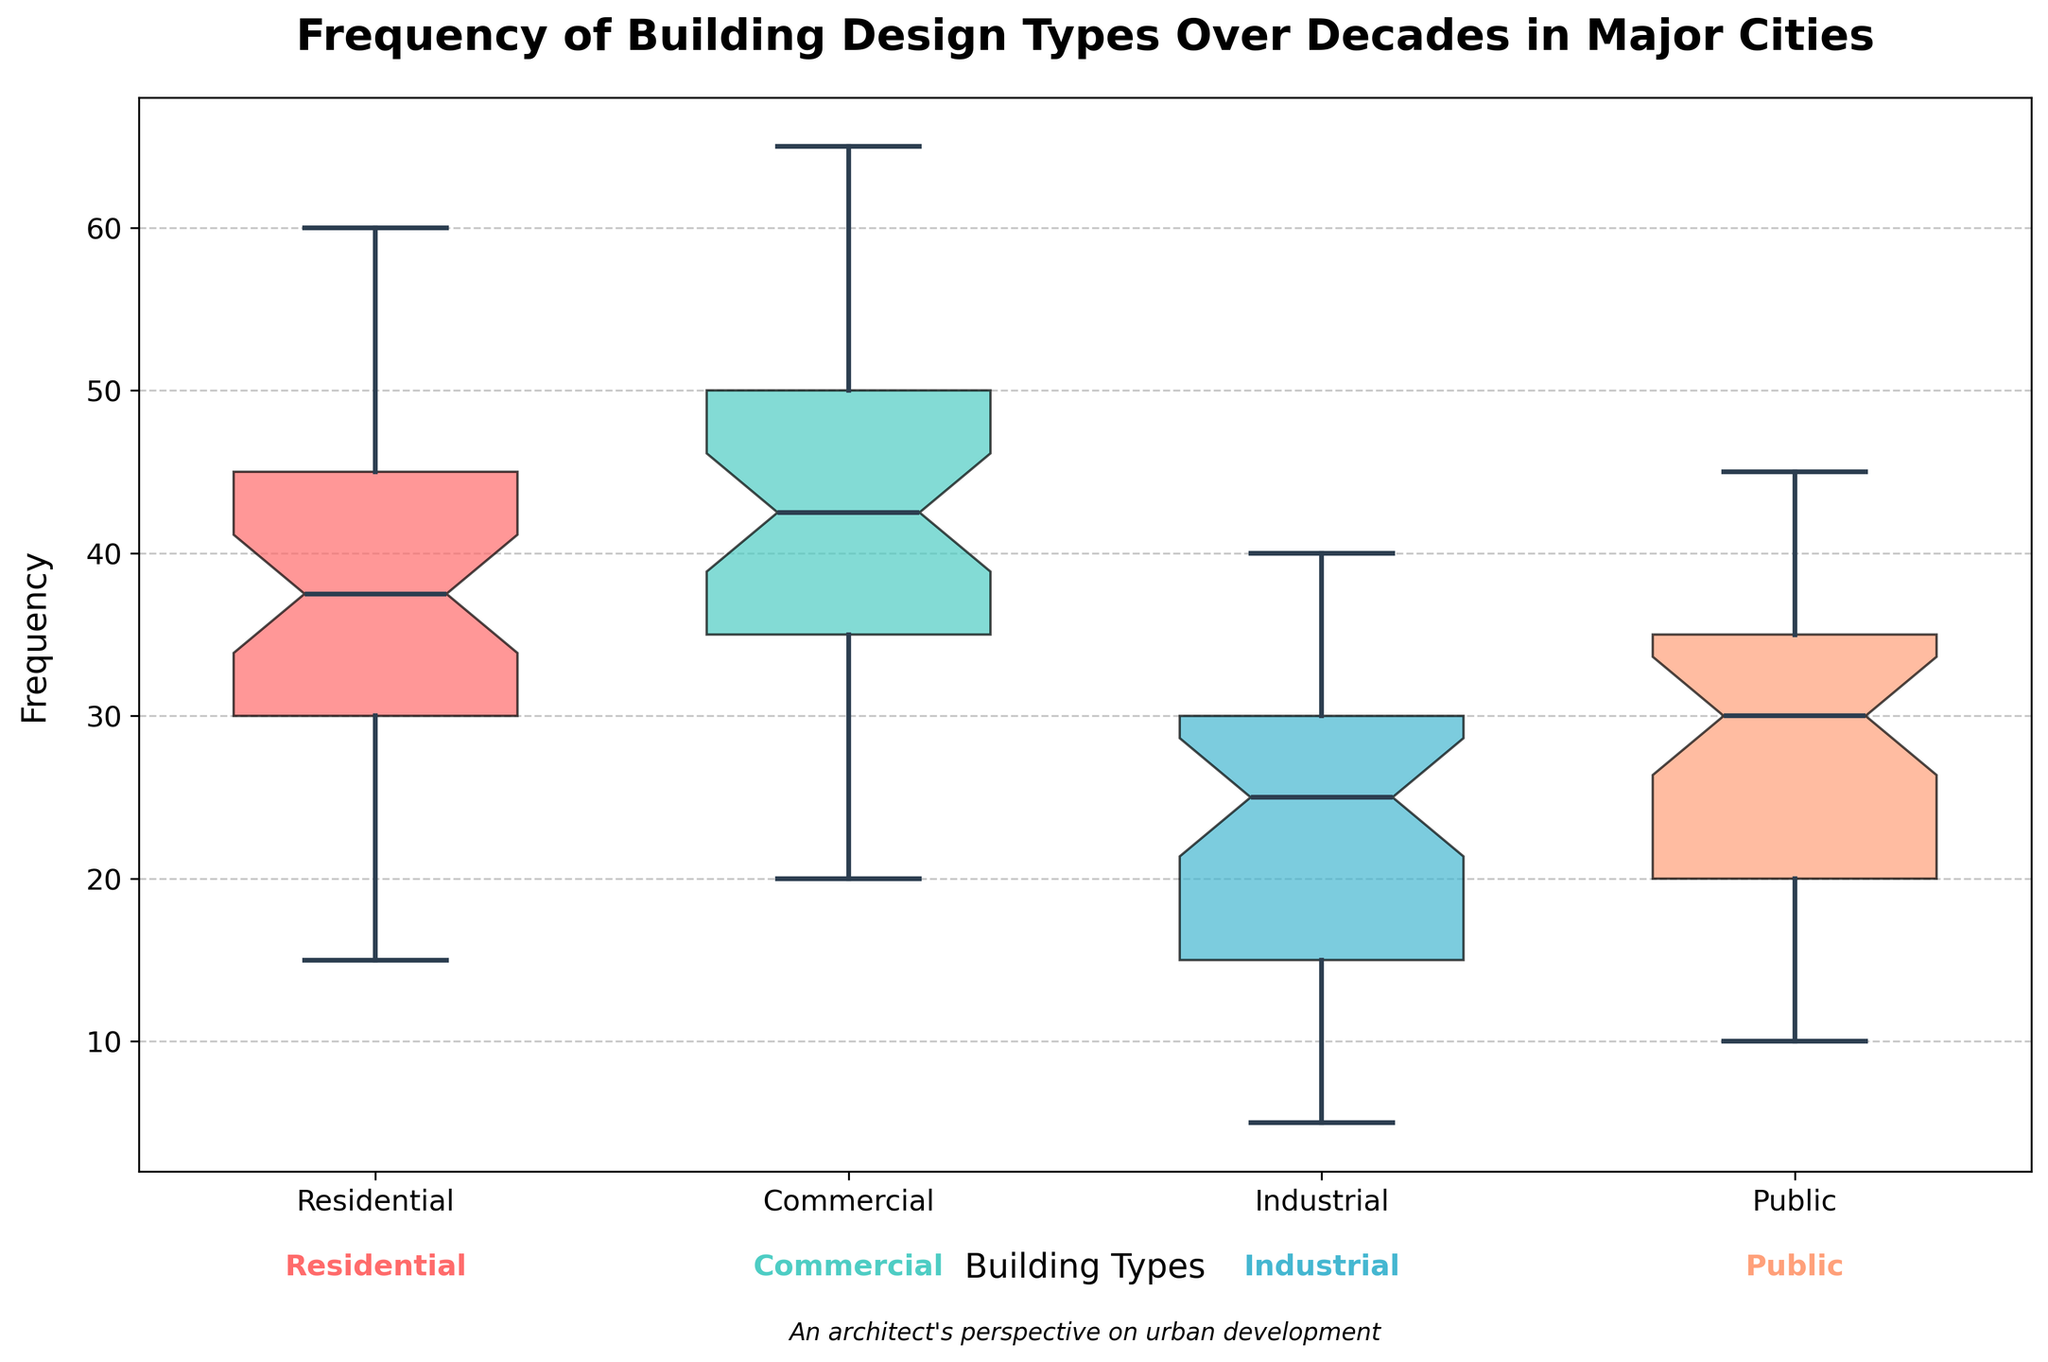What is the title of the figure? The title is typically at the top of a chart and describes what the chart is about. Here, it is bold and contains the main topic.
Answer: Frequency of Building Design Types Over Decades in Major Cities Which building type has the highest median frequency? To find the median frequency for each type, look for the central line inside each box. The type with the highest median line is the one with the highest median frequency.
Answer: Public Which building type shows the widest range in frequency? The range is identified by the length of the box (Interquartile Range) and the whiskers. Examine the box and whisker lengths across the building types to determine which is the widest.
Answer: Residential What's the frequency range for the Commercial building type? The range is the difference between the maximum and minimum values. Look at the top and bottom whiskers for Commercial to determine these values.
Answer: 25-65 Which building type has the least variability in frequency? Variability in a box plot is typically assessed by the length of the box and whiskers. The type with the shortest total length of box and whiskers has the least variability.
Answer: Industrial Is there an outlier in any building type? Outliers in a box plot are typically marked by individual points outside the whiskers. Check for any marked points outside the whiskers for all building types.
Answer: Yes, in Industrial What's the interquartile range (IQR) for Public building types? IQR is the difference between the upper quartile (top of the box) and the lower quartile (bottom of the box). Measure this difference for the Public building type.
Answer: 20 How does the median of Residential compare to the median of Industrial? Compare the central lines inside the boxes of Residential and Industrial. Determine which is higher or if they are equal.
Answer: Residential's median is higher Are there more data points indicating higher frequencies in Public or Industrial building types? This can be assessed by examining the box and whisker lengths and the presence of outliers. If the box and whiskers extend higher, there are more high-frequency points.
Answer: Public How does the range of Commercial building types in the figure compare to Public? Compare the total length of the whiskers for both Commercial and Public. The one with a longer whisker length has a larger range.
Answer: Commercial has a larger range 